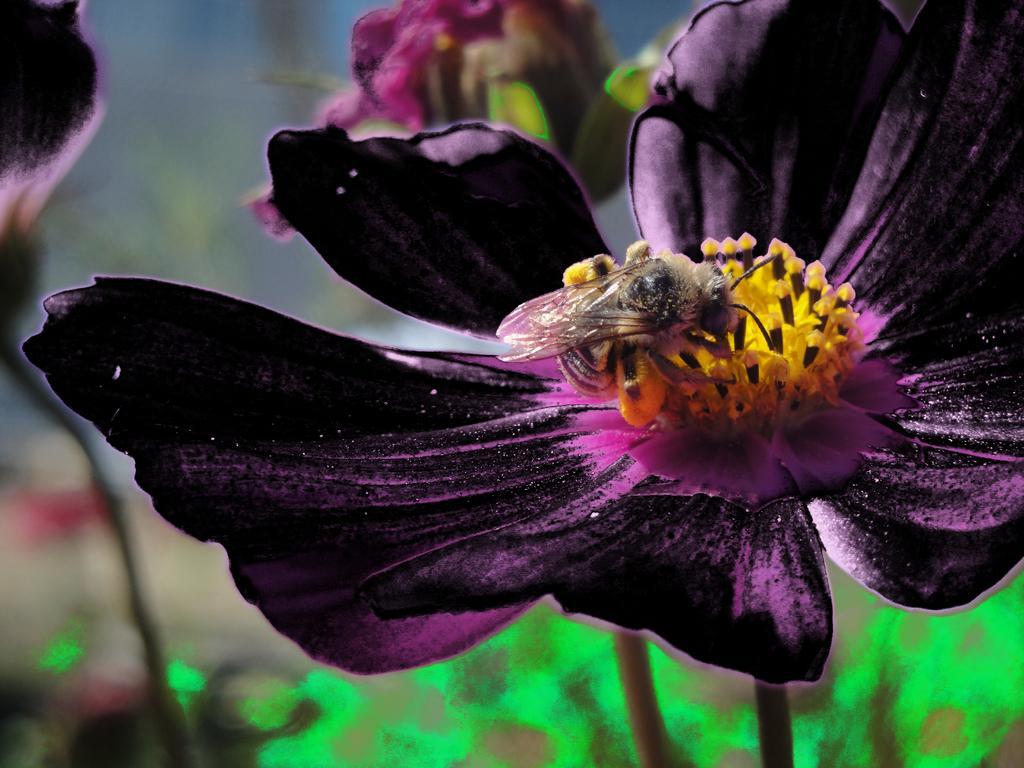How would you summarize this image in a sentence or two? In this image I can see a purple,yellow and black flower and insect is on it. There is a blurred background. 